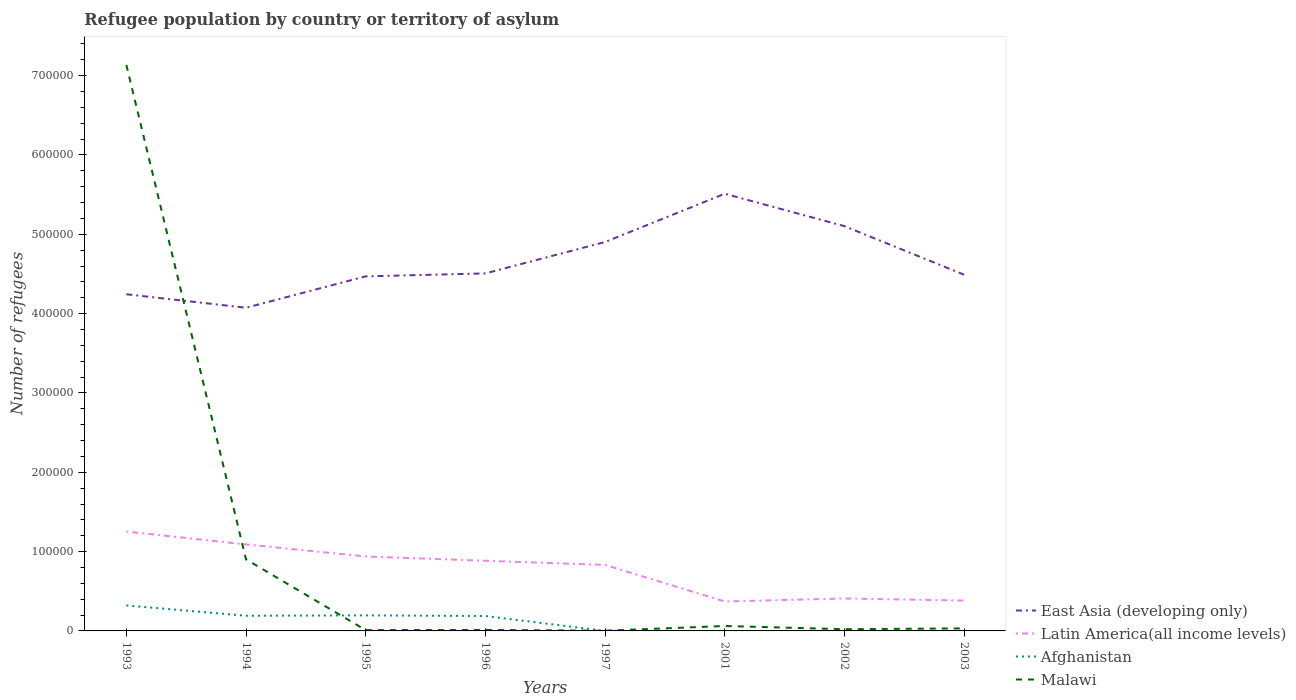Does the line corresponding to Malawi intersect with the line corresponding to Afghanistan?
Offer a terse response. Yes. Across all years, what is the maximum number of refugees in Malawi?
Your answer should be compact. 280. In which year was the number of refugees in Afghanistan maximum?
Your response must be concise. 2002. What is the total number of refugees in Latin America(all income levels) in the graph?
Your response must be concise. 5437. What is the difference between the highest and the second highest number of refugees in Malawi?
Your answer should be very brief. 7.13e+05. What is the difference between the highest and the lowest number of refugees in Malawi?
Provide a short and direct response. 1. What is the difference between two consecutive major ticks on the Y-axis?
Keep it short and to the point. 1.00e+05. Are the values on the major ticks of Y-axis written in scientific E-notation?
Make the answer very short. No. Does the graph contain any zero values?
Your response must be concise. No. How many legend labels are there?
Provide a succinct answer. 4. How are the legend labels stacked?
Your answer should be very brief. Vertical. What is the title of the graph?
Your answer should be very brief. Refugee population by country or territory of asylum. What is the label or title of the X-axis?
Your response must be concise. Years. What is the label or title of the Y-axis?
Your response must be concise. Number of refugees. What is the Number of refugees in East Asia (developing only) in 1993?
Give a very brief answer. 4.24e+05. What is the Number of refugees of Latin America(all income levels) in 1993?
Offer a terse response. 1.25e+05. What is the Number of refugees of Afghanistan in 1993?
Your answer should be compact. 3.21e+04. What is the Number of refugees in Malawi in 1993?
Your response must be concise. 7.14e+05. What is the Number of refugees in East Asia (developing only) in 1994?
Keep it short and to the point. 4.07e+05. What is the Number of refugees of Latin America(all income levels) in 1994?
Your answer should be compact. 1.09e+05. What is the Number of refugees in Afghanistan in 1994?
Your response must be concise. 1.91e+04. What is the Number of refugees of Malawi in 1994?
Offer a very short reply. 9.02e+04. What is the Number of refugees of East Asia (developing only) in 1995?
Offer a terse response. 4.47e+05. What is the Number of refugees of Latin America(all income levels) in 1995?
Your response must be concise. 9.39e+04. What is the Number of refugees of Afghanistan in 1995?
Provide a succinct answer. 1.96e+04. What is the Number of refugees of Malawi in 1995?
Provide a succinct answer. 1018. What is the Number of refugees in East Asia (developing only) in 1996?
Your answer should be compact. 4.51e+05. What is the Number of refugees in Latin America(all income levels) in 1996?
Make the answer very short. 8.84e+04. What is the Number of refugees in Afghanistan in 1996?
Offer a terse response. 1.88e+04. What is the Number of refugees in Malawi in 1996?
Give a very brief answer. 1268. What is the Number of refugees of East Asia (developing only) in 1997?
Keep it short and to the point. 4.90e+05. What is the Number of refugees in Latin America(all income levels) in 1997?
Ensure brevity in your answer.  8.32e+04. What is the Number of refugees of Afghanistan in 1997?
Your response must be concise. 5. What is the Number of refugees of Malawi in 1997?
Make the answer very short. 280. What is the Number of refugees in East Asia (developing only) in 2001?
Keep it short and to the point. 5.51e+05. What is the Number of refugees of Latin America(all income levels) in 2001?
Offer a very short reply. 3.71e+04. What is the Number of refugees of Malawi in 2001?
Ensure brevity in your answer.  6200. What is the Number of refugees in East Asia (developing only) in 2002?
Make the answer very short. 5.10e+05. What is the Number of refugees of Latin America(all income levels) in 2002?
Provide a short and direct response. 4.09e+04. What is the Number of refugees in Malawi in 2002?
Provide a succinct answer. 2166. What is the Number of refugees of East Asia (developing only) in 2003?
Make the answer very short. 4.49e+05. What is the Number of refugees in Latin America(all income levels) in 2003?
Give a very brief answer. 3.83e+04. What is the Number of refugees of Malawi in 2003?
Provide a short and direct response. 3202. Across all years, what is the maximum Number of refugees of East Asia (developing only)?
Ensure brevity in your answer.  5.51e+05. Across all years, what is the maximum Number of refugees of Latin America(all income levels)?
Your response must be concise. 1.25e+05. Across all years, what is the maximum Number of refugees in Afghanistan?
Your response must be concise. 3.21e+04. Across all years, what is the maximum Number of refugees in Malawi?
Ensure brevity in your answer.  7.14e+05. Across all years, what is the minimum Number of refugees of East Asia (developing only)?
Keep it short and to the point. 4.07e+05. Across all years, what is the minimum Number of refugees of Latin America(all income levels)?
Your answer should be very brief. 3.71e+04. Across all years, what is the minimum Number of refugees of Afghanistan?
Provide a short and direct response. 3. Across all years, what is the minimum Number of refugees of Malawi?
Give a very brief answer. 280. What is the total Number of refugees in East Asia (developing only) in the graph?
Provide a short and direct response. 3.73e+06. What is the total Number of refugees of Latin America(all income levels) in the graph?
Make the answer very short. 6.16e+05. What is the total Number of refugees of Afghanistan in the graph?
Give a very brief answer. 8.97e+04. What is the total Number of refugees of Malawi in the graph?
Keep it short and to the point. 8.18e+05. What is the difference between the Number of refugees of East Asia (developing only) in 1993 and that in 1994?
Ensure brevity in your answer.  1.70e+04. What is the difference between the Number of refugees in Latin America(all income levels) in 1993 and that in 1994?
Give a very brief answer. 1.62e+04. What is the difference between the Number of refugees in Afghanistan in 1993 and that in 1994?
Give a very brief answer. 1.30e+04. What is the difference between the Number of refugees in Malawi in 1993 and that in 1994?
Provide a succinct answer. 6.23e+05. What is the difference between the Number of refugees of East Asia (developing only) in 1993 and that in 1995?
Ensure brevity in your answer.  -2.25e+04. What is the difference between the Number of refugees in Latin America(all income levels) in 1993 and that in 1995?
Provide a succinct answer. 3.14e+04. What is the difference between the Number of refugees in Afghanistan in 1993 and that in 1995?
Your answer should be compact. 1.25e+04. What is the difference between the Number of refugees of Malawi in 1993 and that in 1995?
Offer a terse response. 7.13e+05. What is the difference between the Number of refugees in East Asia (developing only) in 1993 and that in 1996?
Offer a terse response. -2.63e+04. What is the difference between the Number of refugees in Latin America(all income levels) in 1993 and that in 1996?
Make the answer very short. 3.69e+04. What is the difference between the Number of refugees of Afghanistan in 1993 and that in 1996?
Offer a very short reply. 1.34e+04. What is the difference between the Number of refugees in Malawi in 1993 and that in 1996?
Make the answer very short. 7.12e+05. What is the difference between the Number of refugees in East Asia (developing only) in 1993 and that in 1997?
Give a very brief answer. -6.59e+04. What is the difference between the Number of refugees in Latin America(all income levels) in 1993 and that in 1997?
Provide a short and direct response. 4.21e+04. What is the difference between the Number of refugees of Afghanistan in 1993 and that in 1997?
Offer a very short reply. 3.21e+04. What is the difference between the Number of refugees of Malawi in 1993 and that in 1997?
Your answer should be very brief. 7.13e+05. What is the difference between the Number of refugees of East Asia (developing only) in 1993 and that in 2001?
Offer a terse response. -1.27e+05. What is the difference between the Number of refugees of Latin America(all income levels) in 1993 and that in 2001?
Offer a very short reply. 8.82e+04. What is the difference between the Number of refugees of Afghanistan in 1993 and that in 2001?
Make the answer very short. 3.21e+04. What is the difference between the Number of refugees in Malawi in 1993 and that in 2001?
Make the answer very short. 7.07e+05. What is the difference between the Number of refugees of East Asia (developing only) in 1993 and that in 2002?
Give a very brief answer. -8.59e+04. What is the difference between the Number of refugees in Latin America(all income levels) in 1993 and that in 2002?
Make the answer very short. 8.44e+04. What is the difference between the Number of refugees in Afghanistan in 1993 and that in 2002?
Ensure brevity in your answer.  3.21e+04. What is the difference between the Number of refugees of Malawi in 1993 and that in 2002?
Make the answer very short. 7.11e+05. What is the difference between the Number of refugees of East Asia (developing only) in 1993 and that in 2003?
Your response must be concise. -2.47e+04. What is the difference between the Number of refugees of Latin America(all income levels) in 1993 and that in 2003?
Offer a terse response. 8.70e+04. What is the difference between the Number of refugees of Afghanistan in 1993 and that in 2003?
Provide a succinct answer. 3.21e+04. What is the difference between the Number of refugees in Malawi in 1993 and that in 2003?
Give a very brief answer. 7.10e+05. What is the difference between the Number of refugees in East Asia (developing only) in 1994 and that in 1995?
Give a very brief answer. -3.96e+04. What is the difference between the Number of refugees of Latin America(all income levels) in 1994 and that in 1995?
Give a very brief answer. 1.52e+04. What is the difference between the Number of refugees in Afghanistan in 1994 and that in 1995?
Give a very brief answer. -474. What is the difference between the Number of refugees of Malawi in 1994 and that in 1995?
Provide a short and direct response. 8.92e+04. What is the difference between the Number of refugees of East Asia (developing only) in 1994 and that in 1996?
Provide a short and direct response. -4.33e+04. What is the difference between the Number of refugees in Latin America(all income levels) in 1994 and that in 1996?
Keep it short and to the point. 2.06e+04. What is the difference between the Number of refugees of Afghanistan in 1994 and that in 1996?
Your answer should be compact. 356. What is the difference between the Number of refugees in Malawi in 1994 and that in 1996?
Ensure brevity in your answer.  8.90e+04. What is the difference between the Number of refugees of East Asia (developing only) in 1994 and that in 1997?
Your response must be concise. -8.29e+04. What is the difference between the Number of refugees of Latin America(all income levels) in 1994 and that in 1997?
Your answer should be compact. 2.58e+04. What is the difference between the Number of refugees in Afghanistan in 1994 and that in 1997?
Offer a terse response. 1.91e+04. What is the difference between the Number of refugees of Malawi in 1994 and that in 1997?
Your answer should be compact. 9.00e+04. What is the difference between the Number of refugees of East Asia (developing only) in 1994 and that in 2001?
Your answer should be compact. -1.44e+05. What is the difference between the Number of refugees in Latin America(all income levels) in 1994 and that in 2001?
Offer a terse response. 7.19e+04. What is the difference between the Number of refugees of Afghanistan in 1994 and that in 2001?
Provide a succinct answer. 1.91e+04. What is the difference between the Number of refugees in Malawi in 1994 and that in 2001?
Give a very brief answer. 8.40e+04. What is the difference between the Number of refugees of East Asia (developing only) in 1994 and that in 2002?
Keep it short and to the point. -1.03e+05. What is the difference between the Number of refugees of Latin America(all income levels) in 1994 and that in 2002?
Your response must be concise. 6.82e+04. What is the difference between the Number of refugees in Afghanistan in 1994 and that in 2002?
Provide a short and direct response. 1.91e+04. What is the difference between the Number of refugees of Malawi in 1994 and that in 2002?
Your answer should be compact. 8.81e+04. What is the difference between the Number of refugees of East Asia (developing only) in 1994 and that in 2003?
Keep it short and to the point. -4.17e+04. What is the difference between the Number of refugees of Latin America(all income levels) in 1994 and that in 2003?
Make the answer very short. 7.07e+04. What is the difference between the Number of refugees of Afghanistan in 1994 and that in 2003?
Offer a terse response. 1.91e+04. What is the difference between the Number of refugees in Malawi in 1994 and that in 2003?
Provide a short and direct response. 8.70e+04. What is the difference between the Number of refugees of East Asia (developing only) in 1995 and that in 1996?
Offer a terse response. -3745. What is the difference between the Number of refugees in Latin America(all income levels) in 1995 and that in 1996?
Make the answer very short. 5437. What is the difference between the Number of refugees of Afghanistan in 1995 and that in 1996?
Your answer should be very brief. 830. What is the difference between the Number of refugees in Malawi in 1995 and that in 1996?
Provide a succinct answer. -250. What is the difference between the Number of refugees of East Asia (developing only) in 1995 and that in 1997?
Give a very brief answer. -4.33e+04. What is the difference between the Number of refugees of Latin America(all income levels) in 1995 and that in 1997?
Provide a succinct answer. 1.06e+04. What is the difference between the Number of refugees of Afghanistan in 1995 and that in 1997?
Provide a succinct answer. 1.96e+04. What is the difference between the Number of refugees in Malawi in 1995 and that in 1997?
Offer a very short reply. 738. What is the difference between the Number of refugees in East Asia (developing only) in 1995 and that in 2001?
Your response must be concise. -1.04e+05. What is the difference between the Number of refugees of Latin America(all income levels) in 1995 and that in 2001?
Provide a short and direct response. 5.67e+04. What is the difference between the Number of refugees of Afghanistan in 1995 and that in 2001?
Give a very brief answer. 1.96e+04. What is the difference between the Number of refugees in Malawi in 1995 and that in 2001?
Give a very brief answer. -5182. What is the difference between the Number of refugees of East Asia (developing only) in 1995 and that in 2002?
Your answer should be compact. -6.33e+04. What is the difference between the Number of refugees of Latin America(all income levels) in 1995 and that in 2002?
Give a very brief answer. 5.30e+04. What is the difference between the Number of refugees of Afghanistan in 1995 and that in 2002?
Provide a short and direct response. 1.96e+04. What is the difference between the Number of refugees of Malawi in 1995 and that in 2002?
Offer a terse response. -1148. What is the difference between the Number of refugees of East Asia (developing only) in 1995 and that in 2003?
Make the answer very short. -2123. What is the difference between the Number of refugees in Latin America(all income levels) in 1995 and that in 2003?
Ensure brevity in your answer.  5.56e+04. What is the difference between the Number of refugees of Afghanistan in 1995 and that in 2003?
Your answer should be very brief. 1.96e+04. What is the difference between the Number of refugees of Malawi in 1995 and that in 2003?
Give a very brief answer. -2184. What is the difference between the Number of refugees of East Asia (developing only) in 1996 and that in 1997?
Provide a succinct answer. -3.96e+04. What is the difference between the Number of refugees of Latin America(all income levels) in 1996 and that in 1997?
Your answer should be compact. 5201. What is the difference between the Number of refugees of Afghanistan in 1996 and that in 1997?
Your answer should be very brief. 1.88e+04. What is the difference between the Number of refugees in Malawi in 1996 and that in 1997?
Offer a terse response. 988. What is the difference between the Number of refugees of East Asia (developing only) in 1996 and that in 2001?
Provide a succinct answer. -1.00e+05. What is the difference between the Number of refugees in Latin America(all income levels) in 1996 and that in 2001?
Provide a succinct answer. 5.13e+04. What is the difference between the Number of refugees in Afghanistan in 1996 and that in 2001?
Provide a succinct answer. 1.88e+04. What is the difference between the Number of refugees in Malawi in 1996 and that in 2001?
Provide a succinct answer. -4932. What is the difference between the Number of refugees in East Asia (developing only) in 1996 and that in 2002?
Ensure brevity in your answer.  -5.96e+04. What is the difference between the Number of refugees in Latin America(all income levels) in 1996 and that in 2002?
Your response must be concise. 4.75e+04. What is the difference between the Number of refugees in Afghanistan in 1996 and that in 2002?
Give a very brief answer. 1.88e+04. What is the difference between the Number of refugees in Malawi in 1996 and that in 2002?
Ensure brevity in your answer.  -898. What is the difference between the Number of refugees in East Asia (developing only) in 1996 and that in 2003?
Ensure brevity in your answer.  1622. What is the difference between the Number of refugees of Latin America(all income levels) in 1996 and that in 2003?
Provide a succinct answer. 5.01e+04. What is the difference between the Number of refugees in Afghanistan in 1996 and that in 2003?
Your answer should be compact. 1.88e+04. What is the difference between the Number of refugees of Malawi in 1996 and that in 2003?
Offer a very short reply. -1934. What is the difference between the Number of refugees in East Asia (developing only) in 1997 and that in 2001?
Ensure brevity in your answer.  -6.08e+04. What is the difference between the Number of refugees in Latin America(all income levels) in 1997 and that in 2001?
Keep it short and to the point. 4.61e+04. What is the difference between the Number of refugees in Malawi in 1997 and that in 2001?
Provide a succinct answer. -5920. What is the difference between the Number of refugees in East Asia (developing only) in 1997 and that in 2002?
Your answer should be very brief. -2.00e+04. What is the difference between the Number of refugees of Latin America(all income levels) in 1997 and that in 2002?
Offer a very short reply. 4.23e+04. What is the difference between the Number of refugees of Malawi in 1997 and that in 2002?
Offer a very short reply. -1886. What is the difference between the Number of refugees of East Asia (developing only) in 1997 and that in 2003?
Offer a terse response. 4.12e+04. What is the difference between the Number of refugees of Latin America(all income levels) in 1997 and that in 2003?
Make the answer very short. 4.49e+04. What is the difference between the Number of refugees of Afghanistan in 1997 and that in 2003?
Ensure brevity in your answer.  -17. What is the difference between the Number of refugees of Malawi in 1997 and that in 2003?
Provide a succinct answer. -2922. What is the difference between the Number of refugees in East Asia (developing only) in 2001 and that in 2002?
Offer a very short reply. 4.08e+04. What is the difference between the Number of refugees of Latin America(all income levels) in 2001 and that in 2002?
Offer a very short reply. -3747. What is the difference between the Number of refugees in Malawi in 2001 and that in 2002?
Keep it short and to the point. 4034. What is the difference between the Number of refugees in East Asia (developing only) in 2001 and that in 2003?
Make the answer very short. 1.02e+05. What is the difference between the Number of refugees in Latin America(all income levels) in 2001 and that in 2003?
Offer a terse response. -1168. What is the difference between the Number of refugees in Malawi in 2001 and that in 2003?
Your answer should be compact. 2998. What is the difference between the Number of refugees of East Asia (developing only) in 2002 and that in 2003?
Your answer should be compact. 6.12e+04. What is the difference between the Number of refugees in Latin America(all income levels) in 2002 and that in 2003?
Provide a short and direct response. 2579. What is the difference between the Number of refugees in Afghanistan in 2002 and that in 2003?
Ensure brevity in your answer.  -19. What is the difference between the Number of refugees of Malawi in 2002 and that in 2003?
Provide a short and direct response. -1036. What is the difference between the Number of refugees in East Asia (developing only) in 1993 and the Number of refugees in Latin America(all income levels) in 1994?
Offer a terse response. 3.15e+05. What is the difference between the Number of refugees of East Asia (developing only) in 1993 and the Number of refugees of Afghanistan in 1994?
Ensure brevity in your answer.  4.05e+05. What is the difference between the Number of refugees of East Asia (developing only) in 1993 and the Number of refugees of Malawi in 1994?
Make the answer very short. 3.34e+05. What is the difference between the Number of refugees in Latin America(all income levels) in 1993 and the Number of refugees in Afghanistan in 1994?
Your answer should be compact. 1.06e+05. What is the difference between the Number of refugees of Latin America(all income levels) in 1993 and the Number of refugees of Malawi in 1994?
Give a very brief answer. 3.50e+04. What is the difference between the Number of refugees of Afghanistan in 1993 and the Number of refugees of Malawi in 1994?
Ensure brevity in your answer.  -5.81e+04. What is the difference between the Number of refugees in East Asia (developing only) in 1993 and the Number of refugees in Latin America(all income levels) in 1995?
Offer a terse response. 3.31e+05. What is the difference between the Number of refugees of East Asia (developing only) in 1993 and the Number of refugees of Afghanistan in 1995?
Provide a short and direct response. 4.05e+05. What is the difference between the Number of refugees of East Asia (developing only) in 1993 and the Number of refugees of Malawi in 1995?
Make the answer very short. 4.23e+05. What is the difference between the Number of refugees in Latin America(all income levels) in 1993 and the Number of refugees in Afghanistan in 1995?
Your answer should be very brief. 1.06e+05. What is the difference between the Number of refugees of Latin America(all income levels) in 1993 and the Number of refugees of Malawi in 1995?
Offer a very short reply. 1.24e+05. What is the difference between the Number of refugees in Afghanistan in 1993 and the Number of refugees in Malawi in 1995?
Make the answer very short. 3.11e+04. What is the difference between the Number of refugees in East Asia (developing only) in 1993 and the Number of refugees in Latin America(all income levels) in 1996?
Offer a terse response. 3.36e+05. What is the difference between the Number of refugees in East Asia (developing only) in 1993 and the Number of refugees in Afghanistan in 1996?
Give a very brief answer. 4.06e+05. What is the difference between the Number of refugees of East Asia (developing only) in 1993 and the Number of refugees of Malawi in 1996?
Your response must be concise. 4.23e+05. What is the difference between the Number of refugees of Latin America(all income levels) in 1993 and the Number of refugees of Afghanistan in 1996?
Your answer should be compact. 1.07e+05. What is the difference between the Number of refugees in Latin America(all income levels) in 1993 and the Number of refugees in Malawi in 1996?
Give a very brief answer. 1.24e+05. What is the difference between the Number of refugees in Afghanistan in 1993 and the Number of refugees in Malawi in 1996?
Your response must be concise. 3.09e+04. What is the difference between the Number of refugees in East Asia (developing only) in 1993 and the Number of refugees in Latin America(all income levels) in 1997?
Provide a succinct answer. 3.41e+05. What is the difference between the Number of refugees of East Asia (developing only) in 1993 and the Number of refugees of Afghanistan in 1997?
Your answer should be very brief. 4.24e+05. What is the difference between the Number of refugees of East Asia (developing only) in 1993 and the Number of refugees of Malawi in 1997?
Make the answer very short. 4.24e+05. What is the difference between the Number of refugees of Latin America(all income levels) in 1993 and the Number of refugees of Afghanistan in 1997?
Offer a terse response. 1.25e+05. What is the difference between the Number of refugees in Latin America(all income levels) in 1993 and the Number of refugees in Malawi in 1997?
Keep it short and to the point. 1.25e+05. What is the difference between the Number of refugees in Afghanistan in 1993 and the Number of refugees in Malawi in 1997?
Make the answer very short. 3.19e+04. What is the difference between the Number of refugees of East Asia (developing only) in 1993 and the Number of refugees of Latin America(all income levels) in 2001?
Provide a succinct answer. 3.87e+05. What is the difference between the Number of refugees in East Asia (developing only) in 1993 and the Number of refugees in Afghanistan in 2001?
Offer a very short reply. 4.24e+05. What is the difference between the Number of refugees of East Asia (developing only) in 1993 and the Number of refugees of Malawi in 2001?
Offer a very short reply. 4.18e+05. What is the difference between the Number of refugees in Latin America(all income levels) in 1993 and the Number of refugees in Afghanistan in 2001?
Offer a very short reply. 1.25e+05. What is the difference between the Number of refugees of Latin America(all income levels) in 1993 and the Number of refugees of Malawi in 2001?
Your answer should be compact. 1.19e+05. What is the difference between the Number of refugees in Afghanistan in 1993 and the Number of refugees in Malawi in 2001?
Offer a terse response. 2.59e+04. What is the difference between the Number of refugees of East Asia (developing only) in 1993 and the Number of refugees of Latin America(all income levels) in 2002?
Your answer should be very brief. 3.84e+05. What is the difference between the Number of refugees in East Asia (developing only) in 1993 and the Number of refugees in Afghanistan in 2002?
Provide a succinct answer. 4.24e+05. What is the difference between the Number of refugees in East Asia (developing only) in 1993 and the Number of refugees in Malawi in 2002?
Your answer should be compact. 4.22e+05. What is the difference between the Number of refugees in Latin America(all income levels) in 1993 and the Number of refugees in Afghanistan in 2002?
Ensure brevity in your answer.  1.25e+05. What is the difference between the Number of refugees in Latin America(all income levels) in 1993 and the Number of refugees in Malawi in 2002?
Ensure brevity in your answer.  1.23e+05. What is the difference between the Number of refugees of Afghanistan in 1993 and the Number of refugees of Malawi in 2002?
Provide a succinct answer. 3.00e+04. What is the difference between the Number of refugees of East Asia (developing only) in 1993 and the Number of refugees of Latin America(all income levels) in 2003?
Provide a succinct answer. 3.86e+05. What is the difference between the Number of refugees in East Asia (developing only) in 1993 and the Number of refugees in Afghanistan in 2003?
Offer a very short reply. 4.24e+05. What is the difference between the Number of refugees of East Asia (developing only) in 1993 and the Number of refugees of Malawi in 2003?
Offer a terse response. 4.21e+05. What is the difference between the Number of refugees in Latin America(all income levels) in 1993 and the Number of refugees in Afghanistan in 2003?
Your answer should be compact. 1.25e+05. What is the difference between the Number of refugees of Latin America(all income levels) in 1993 and the Number of refugees of Malawi in 2003?
Offer a very short reply. 1.22e+05. What is the difference between the Number of refugees of Afghanistan in 1993 and the Number of refugees of Malawi in 2003?
Give a very brief answer. 2.89e+04. What is the difference between the Number of refugees of East Asia (developing only) in 1994 and the Number of refugees of Latin America(all income levels) in 1995?
Ensure brevity in your answer.  3.14e+05. What is the difference between the Number of refugees in East Asia (developing only) in 1994 and the Number of refugees in Afghanistan in 1995?
Make the answer very short. 3.88e+05. What is the difference between the Number of refugees of East Asia (developing only) in 1994 and the Number of refugees of Malawi in 1995?
Your answer should be very brief. 4.06e+05. What is the difference between the Number of refugees in Latin America(all income levels) in 1994 and the Number of refugees in Afghanistan in 1995?
Give a very brief answer. 8.94e+04. What is the difference between the Number of refugees of Latin America(all income levels) in 1994 and the Number of refugees of Malawi in 1995?
Provide a succinct answer. 1.08e+05. What is the difference between the Number of refugees in Afghanistan in 1994 and the Number of refugees in Malawi in 1995?
Offer a terse response. 1.81e+04. What is the difference between the Number of refugees in East Asia (developing only) in 1994 and the Number of refugees in Latin America(all income levels) in 1996?
Make the answer very short. 3.19e+05. What is the difference between the Number of refugees of East Asia (developing only) in 1994 and the Number of refugees of Afghanistan in 1996?
Provide a short and direct response. 3.89e+05. What is the difference between the Number of refugees of East Asia (developing only) in 1994 and the Number of refugees of Malawi in 1996?
Provide a succinct answer. 4.06e+05. What is the difference between the Number of refugees in Latin America(all income levels) in 1994 and the Number of refugees in Afghanistan in 1996?
Your response must be concise. 9.03e+04. What is the difference between the Number of refugees of Latin America(all income levels) in 1994 and the Number of refugees of Malawi in 1996?
Make the answer very short. 1.08e+05. What is the difference between the Number of refugees of Afghanistan in 1994 and the Number of refugees of Malawi in 1996?
Your answer should be very brief. 1.79e+04. What is the difference between the Number of refugees of East Asia (developing only) in 1994 and the Number of refugees of Latin America(all income levels) in 1997?
Your answer should be compact. 3.24e+05. What is the difference between the Number of refugees in East Asia (developing only) in 1994 and the Number of refugees in Afghanistan in 1997?
Offer a very short reply. 4.07e+05. What is the difference between the Number of refugees in East Asia (developing only) in 1994 and the Number of refugees in Malawi in 1997?
Make the answer very short. 4.07e+05. What is the difference between the Number of refugees in Latin America(all income levels) in 1994 and the Number of refugees in Afghanistan in 1997?
Your answer should be very brief. 1.09e+05. What is the difference between the Number of refugees in Latin America(all income levels) in 1994 and the Number of refugees in Malawi in 1997?
Offer a very short reply. 1.09e+05. What is the difference between the Number of refugees in Afghanistan in 1994 and the Number of refugees in Malawi in 1997?
Provide a short and direct response. 1.89e+04. What is the difference between the Number of refugees in East Asia (developing only) in 1994 and the Number of refugees in Latin America(all income levels) in 2001?
Make the answer very short. 3.70e+05. What is the difference between the Number of refugees in East Asia (developing only) in 1994 and the Number of refugees in Afghanistan in 2001?
Offer a terse response. 4.07e+05. What is the difference between the Number of refugees of East Asia (developing only) in 1994 and the Number of refugees of Malawi in 2001?
Your answer should be very brief. 4.01e+05. What is the difference between the Number of refugees of Latin America(all income levels) in 1994 and the Number of refugees of Afghanistan in 2001?
Ensure brevity in your answer.  1.09e+05. What is the difference between the Number of refugees in Latin America(all income levels) in 1994 and the Number of refugees in Malawi in 2001?
Provide a short and direct response. 1.03e+05. What is the difference between the Number of refugees of Afghanistan in 1994 and the Number of refugees of Malawi in 2001?
Provide a short and direct response. 1.29e+04. What is the difference between the Number of refugees of East Asia (developing only) in 1994 and the Number of refugees of Latin America(all income levels) in 2002?
Provide a short and direct response. 3.67e+05. What is the difference between the Number of refugees in East Asia (developing only) in 1994 and the Number of refugees in Afghanistan in 2002?
Provide a succinct answer. 4.07e+05. What is the difference between the Number of refugees in East Asia (developing only) in 1994 and the Number of refugees in Malawi in 2002?
Make the answer very short. 4.05e+05. What is the difference between the Number of refugees of Latin America(all income levels) in 1994 and the Number of refugees of Afghanistan in 2002?
Make the answer very short. 1.09e+05. What is the difference between the Number of refugees of Latin America(all income levels) in 1994 and the Number of refugees of Malawi in 2002?
Ensure brevity in your answer.  1.07e+05. What is the difference between the Number of refugees in Afghanistan in 1994 and the Number of refugees in Malawi in 2002?
Your answer should be compact. 1.70e+04. What is the difference between the Number of refugees of East Asia (developing only) in 1994 and the Number of refugees of Latin America(all income levels) in 2003?
Offer a terse response. 3.69e+05. What is the difference between the Number of refugees in East Asia (developing only) in 1994 and the Number of refugees in Afghanistan in 2003?
Offer a terse response. 4.07e+05. What is the difference between the Number of refugees in East Asia (developing only) in 1994 and the Number of refugees in Malawi in 2003?
Keep it short and to the point. 4.04e+05. What is the difference between the Number of refugees in Latin America(all income levels) in 1994 and the Number of refugees in Afghanistan in 2003?
Give a very brief answer. 1.09e+05. What is the difference between the Number of refugees in Latin America(all income levels) in 1994 and the Number of refugees in Malawi in 2003?
Provide a succinct answer. 1.06e+05. What is the difference between the Number of refugees of Afghanistan in 1994 and the Number of refugees of Malawi in 2003?
Offer a terse response. 1.59e+04. What is the difference between the Number of refugees in East Asia (developing only) in 1995 and the Number of refugees in Latin America(all income levels) in 1996?
Ensure brevity in your answer.  3.59e+05. What is the difference between the Number of refugees in East Asia (developing only) in 1995 and the Number of refugees in Afghanistan in 1996?
Make the answer very short. 4.28e+05. What is the difference between the Number of refugees of East Asia (developing only) in 1995 and the Number of refugees of Malawi in 1996?
Offer a very short reply. 4.46e+05. What is the difference between the Number of refugees in Latin America(all income levels) in 1995 and the Number of refugees in Afghanistan in 1996?
Ensure brevity in your answer.  7.51e+04. What is the difference between the Number of refugees in Latin America(all income levels) in 1995 and the Number of refugees in Malawi in 1996?
Provide a succinct answer. 9.26e+04. What is the difference between the Number of refugees in Afghanistan in 1995 and the Number of refugees in Malawi in 1996?
Your response must be concise. 1.83e+04. What is the difference between the Number of refugees of East Asia (developing only) in 1995 and the Number of refugees of Latin America(all income levels) in 1997?
Ensure brevity in your answer.  3.64e+05. What is the difference between the Number of refugees of East Asia (developing only) in 1995 and the Number of refugees of Afghanistan in 1997?
Offer a very short reply. 4.47e+05. What is the difference between the Number of refugees of East Asia (developing only) in 1995 and the Number of refugees of Malawi in 1997?
Your answer should be compact. 4.47e+05. What is the difference between the Number of refugees of Latin America(all income levels) in 1995 and the Number of refugees of Afghanistan in 1997?
Your answer should be very brief. 9.39e+04. What is the difference between the Number of refugees of Latin America(all income levels) in 1995 and the Number of refugees of Malawi in 1997?
Your answer should be compact. 9.36e+04. What is the difference between the Number of refugees in Afghanistan in 1995 and the Number of refugees in Malawi in 1997?
Make the answer very short. 1.93e+04. What is the difference between the Number of refugees of East Asia (developing only) in 1995 and the Number of refugees of Latin America(all income levels) in 2001?
Your response must be concise. 4.10e+05. What is the difference between the Number of refugees in East Asia (developing only) in 1995 and the Number of refugees in Afghanistan in 2001?
Ensure brevity in your answer.  4.47e+05. What is the difference between the Number of refugees of East Asia (developing only) in 1995 and the Number of refugees of Malawi in 2001?
Ensure brevity in your answer.  4.41e+05. What is the difference between the Number of refugees of Latin America(all income levels) in 1995 and the Number of refugees of Afghanistan in 2001?
Offer a very short reply. 9.39e+04. What is the difference between the Number of refugees of Latin America(all income levels) in 1995 and the Number of refugees of Malawi in 2001?
Your response must be concise. 8.77e+04. What is the difference between the Number of refugees in Afghanistan in 1995 and the Number of refugees in Malawi in 2001?
Keep it short and to the point. 1.34e+04. What is the difference between the Number of refugees of East Asia (developing only) in 1995 and the Number of refugees of Latin America(all income levels) in 2002?
Offer a very short reply. 4.06e+05. What is the difference between the Number of refugees of East Asia (developing only) in 1995 and the Number of refugees of Afghanistan in 2002?
Make the answer very short. 4.47e+05. What is the difference between the Number of refugees of East Asia (developing only) in 1995 and the Number of refugees of Malawi in 2002?
Offer a very short reply. 4.45e+05. What is the difference between the Number of refugees of Latin America(all income levels) in 1995 and the Number of refugees of Afghanistan in 2002?
Provide a succinct answer. 9.39e+04. What is the difference between the Number of refugees of Latin America(all income levels) in 1995 and the Number of refugees of Malawi in 2002?
Your response must be concise. 9.17e+04. What is the difference between the Number of refugees in Afghanistan in 1995 and the Number of refugees in Malawi in 2002?
Your answer should be compact. 1.74e+04. What is the difference between the Number of refugees in East Asia (developing only) in 1995 and the Number of refugees in Latin America(all income levels) in 2003?
Offer a very short reply. 4.09e+05. What is the difference between the Number of refugees in East Asia (developing only) in 1995 and the Number of refugees in Afghanistan in 2003?
Offer a very short reply. 4.47e+05. What is the difference between the Number of refugees in East Asia (developing only) in 1995 and the Number of refugees in Malawi in 2003?
Your answer should be compact. 4.44e+05. What is the difference between the Number of refugees in Latin America(all income levels) in 1995 and the Number of refugees in Afghanistan in 2003?
Your answer should be compact. 9.38e+04. What is the difference between the Number of refugees of Latin America(all income levels) in 1995 and the Number of refugees of Malawi in 2003?
Ensure brevity in your answer.  9.07e+04. What is the difference between the Number of refugees in Afghanistan in 1995 and the Number of refugees in Malawi in 2003?
Make the answer very short. 1.64e+04. What is the difference between the Number of refugees of East Asia (developing only) in 1996 and the Number of refugees of Latin America(all income levels) in 1997?
Offer a very short reply. 3.68e+05. What is the difference between the Number of refugees in East Asia (developing only) in 1996 and the Number of refugees in Afghanistan in 1997?
Your answer should be compact. 4.51e+05. What is the difference between the Number of refugees of East Asia (developing only) in 1996 and the Number of refugees of Malawi in 1997?
Your response must be concise. 4.50e+05. What is the difference between the Number of refugees of Latin America(all income levels) in 1996 and the Number of refugees of Afghanistan in 1997?
Your answer should be very brief. 8.84e+04. What is the difference between the Number of refugees of Latin America(all income levels) in 1996 and the Number of refugees of Malawi in 1997?
Ensure brevity in your answer.  8.81e+04. What is the difference between the Number of refugees in Afghanistan in 1996 and the Number of refugees in Malawi in 1997?
Offer a terse response. 1.85e+04. What is the difference between the Number of refugees in East Asia (developing only) in 1996 and the Number of refugees in Latin America(all income levels) in 2001?
Ensure brevity in your answer.  4.14e+05. What is the difference between the Number of refugees of East Asia (developing only) in 1996 and the Number of refugees of Afghanistan in 2001?
Your answer should be very brief. 4.51e+05. What is the difference between the Number of refugees in East Asia (developing only) in 1996 and the Number of refugees in Malawi in 2001?
Offer a very short reply. 4.45e+05. What is the difference between the Number of refugees in Latin America(all income levels) in 1996 and the Number of refugees in Afghanistan in 2001?
Make the answer very short. 8.84e+04. What is the difference between the Number of refugees in Latin America(all income levels) in 1996 and the Number of refugees in Malawi in 2001?
Your answer should be very brief. 8.22e+04. What is the difference between the Number of refugees of Afghanistan in 1996 and the Number of refugees of Malawi in 2001?
Your response must be concise. 1.26e+04. What is the difference between the Number of refugees of East Asia (developing only) in 1996 and the Number of refugees of Latin America(all income levels) in 2002?
Offer a very short reply. 4.10e+05. What is the difference between the Number of refugees of East Asia (developing only) in 1996 and the Number of refugees of Afghanistan in 2002?
Your answer should be very brief. 4.51e+05. What is the difference between the Number of refugees of East Asia (developing only) in 1996 and the Number of refugees of Malawi in 2002?
Keep it short and to the point. 4.49e+05. What is the difference between the Number of refugees in Latin America(all income levels) in 1996 and the Number of refugees in Afghanistan in 2002?
Your answer should be compact. 8.84e+04. What is the difference between the Number of refugees of Latin America(all income levels) in 1996 and the Number of refugees of Malawi in 2002?
Provide a short and direct response. 8.63e+04. What is the difference between the Number of refugees in Afghanistan in 1996 and the Number of refugees in Malawi in 2002?
Make the answer very short. 1.66e+04. What is the difference between the Number of refugees of East Asia (developing only) in 1996 and the Number of refugees of Latin America(all income levels) in 2003?
Make the answer very short. 4.12e+05. What is the difference between the Number of refugees in East Asia (developing only) in 1996 and the Number of refugees in Afghanistan in 2003?
Ensure brevity in your answer.  4.51e+05. What is the difference between the Number of refugees in East Asia (developing only) in 1996 and the Number of refugees in Malawi in 2003?
Provide a short and direct response. 4.48e+05. What is the difference between the Number of refugees in Latin America(all income levels) in 1996 and the Number of refugees in Afghanistan in 2003?
Your answer should be compact. 8.84e+04. What is the difference between the Number of refugees of Latin America(all income levels) in 1996 and the Number of refugees of Malawi in 2003?
Keep it short and to the point. 8.52e+04. What is the difference between the Number of refugees in Afghanistan in 1996 and the Number of refugees in Malawi in 2003?
Ensure brevity in your answer.  1.56e+04. What is the difference between the Number of refugees in East Asia (developing only) in 1997 and the Number of refugees in Latin America(all income levels) in 2001?
Give a very brief answer. 4.53e+05. What is the difference between the Number of refugees of East Asia (developing only) in 1997 and the Number of refugees of Afghanistan in 2001?
Give a very brief answer. 4.90e+05. What is the difference between the Number of refugees of East Asia (developing only) in 1997 and the Number of refugees of Malawi in 2001?
Your answer should be compact. 4.84e+05. What is the difference between the Number of refugees of Latin America(all income levels) in 1997 and the Number of refugees of Afghanistan in 2001?
Your answer should be very brief. 8.32e+04. What is the difference between the Number of refugees of Latin America(all income levels) in 1997 and the Number of refugees of Malawi in 2001?
Ensure brevity in your answer.  7.70e+04. What is the difference between the Number of refugees in Afghanistan in 1997 and the Number of refugees in Malawi in 2001?
Give a very brief answer. -6195. What is the difference between the Number of refugees of East Asia (developing only) in 1997 and the Number of refugees of Latin America(all income levels) in 2002?
Your answer should be very brief. 4.49e+05. What is the difference between the Number of refugees of East Asia (developing only) in 1997 and the Number of refugees of Afghanistan in 2002?
Ensure brevity in your answer.  4.90e+05. What is the difference between the Number of refugees in East Asia (developing only) in 1997 and the Number of refugees in Malawi in 2002?
Your answer should be very brief. 4.88e+05. What is the difference between the Number of refugees in Latin America(all income levels) in 1997 and the Number of refugees in Afghanistan in 2002?
Your response must be concise. 8.32e+04. What is the difference between the Number of refugees in Latin America(all income levels) in 1997 and the Number of refugees in Malawi in 2002?
Your response must be concise. 8.11e+04. What is the difference between the Number of refugees of Afghanistan in 1997 and the Number of refugees of Malawi in 2002?
Provide a short and direct response. -2161. What is the difference between the Number of refugees in East Asia (developing only) in 1997 and the Number of refugees in Latin America(all income levels) in 2003?
Your answer should be very brief. 4.52e+05. What is the difference between the Number of refugees in East Asia (developing only) in 1997 and the Number of refugees in Afghanistan in 2003?
Give a very brief answer. 4.90e+05. What is the difference between the Number of refugees of East Asia (developing only) in 1997 and the Number of refugees of Malawi in 2003?
Give a very brief answer. 4.87e+05. What is the difference between the Number of refugees in Latin America(all income levels) in 1997 and the Number of refugees in Afghanistan in 2003?
Ensure brevity in your answer.  8.32e+04. What is the difference between the Number of refugees of Latin America(all income levels) in 1997 and the Number of refugees of Malawi in 2003?
Your response must be concise. 8.00e+04. What is the difference between the Number of refugees of Afghanistan in 1997 and the Number of refugees of Malawi in 2003?
Offer a terse response. -3197. What is the difference between the Number of refugees of East Asia (developing only) in 2001 and the Number of refugees of Latin America(all income levels) in 2002?
Ensure brevity in your answer.  5.10e+05. What is the difference between the Number of refugees in East Asia (developing only) in 2001 and the Number of refugees in Afghanistan in 2002?
Offer a terse response. 5.51e+05. What is the difference between the Number of refugees in East Asia (developing only) in 2001 and the Number of refugees in Malawi in 2002?
Keep it short and to the point. 5.49e+05. What is the difference between the Number of refugees in Latin America(all income levels) in 2001 and the Number of refugees in Afghanistan in 2002?
Give a very brief answer. 3.71e+04. What is the difference between the Number of refugees in Latin America(all income levels) in 2001 and the Number of refugees in Malawi in 2002?
Your answer should be compact. 3.50e+04. What is the difference between the Number of refugees in Afghanistan in 2001 and the Number of refugees in Malawi in 2002?
Provide a short and direct response. -2160. What is the difference between the Number of refugees of East Asia (developing only) in 2001 and the Number of refugees of Latin America(all income levels) in 2003?
Your response must be concise. 5.13e+05. What is the difference between the Number of refugees in East Asia (developing only) in 2001 and the Number of refugees in Afghanistan in 2003?
Provide a succinct answer. 5.51e+05. What is the difference between the Number of refugees of East Asia (developing only) in 2001 and the Number of refugees of Malawi in 2003?
Offer a very short reply. 5.48e+05. What is the difference between the Number of refugees in Latin America(all income levels) in 2001 and the Number of refugees in Afghanistan in 2003?
Offer a very short reply. 3.71e+04. What is the difference between the Number of refugees of Latin America(all income levels) in 2001 and the Number of refugees of Malawi in 2003?
Ensure brevity in your answer.  3.39e+04. What is the difference between the Number of refugees in Afghanistan in 2001 and the Number of refugees in Malawi in 2003?
Ensure brevity in your answer.  -3196. What is the difference between the Number of refugees in East Asia (developing only) in 2002 and the Number of refugees in Latin America(all income levels) in 2003?
Your response must be concise. 4.72e+05. What is the difference between the Number of refugees in East Asia (developing only) in 2002 and the Number of refugees in Afghanistan in 2003?
Provide a succinct answer. 5.10e+05. What is the difference between the Number of refugees in East Asia (developing only) in 2002 and the Number of refugees in Malawi in 2003?
Give a very brief answer. 5.07e+05. What is the difference between the Number of refugees in Latin America(all income levels) in 2002 and the Number of refugees in Afghanistan in 2003?
Your answer should be compact. 4.09e+04. What is the difference between the Number of refugees of Latin America(all income levels) in 2002 and the Number of refugees of Malawi in 2003?
Make the answer very short. 3.77e+04. What is the difference between the Number of refugees of Afghanistan in 2002 and the Number of refugees of Malawi in 2003?
Your answer should be very brief. -3199. What is the average Number of refugees in East Asia (developing only) per year?
Provide a short and direct response. 4.66e+05. What is the average Number of refugees in Latin America(all income levels) per year?
Give a very brief answer. 7.70e+04. What is the average Number of refugees of Afghanistan per year?
Provide a succinct answer. 1.12e+04. What is the average Number of refugees of Malawi per year?
Your answer should be compact. 1.02e+05. In the year 1993, what is the difference between the Number of refugees in East Asia (developing only) and Number of refugees in Latin America(all income levels)?
Your response must be concise. 2.99e+05. In the year 1993, what is the difference between the Number of refugees in East Asia (developing only) and Number of refugees in Afghanistan?
Offer a very short reply. 3.92e+05. In the year 1993, what is the difference between the Number of refugees of East Asia (developing only) and Number of refugees of Malawi?
Ensure brevity in your answer.  -2.89e+05. In the year 1993, what is the difference between the Number of refugees of Latin America(all income levels) and Number of refugees of Afghanistan?
Your response must be concise. 9.32e+04. In the year 1993, what is the difference between the Number of refugees in Latin America(all income levels) and Number of refugees in Malawi?
Offer a very short reply. -5.88e+05. In the year 1993, what is the difference between the Number of refugees in Afghanistan and Number of refugees in Malawi?
Your answer should be very brief. -6.81e+05. In the year 1994, what is the difference between the Number of refugees of East Asia (developing only) and Number of refugees of Latin America(all income levels)?
Keep it short and to the point. 2.98e+05. In the year 1994, what is the difference between the Number of refugees of East Asia (developing only) and Number of refugees of Afghanistan?
Your answer should be compact. 3.88e+05. In the year 1994, what is the difference between the Number of refugees of East Asia (developing only) and Number of refugees of Malawi?
Give a very brief answer. 3.17e+05. In the year 1994, what is the difference between the Number of refugees of Latin America(all income levels) and Number of refugees of Afghanistan?
Your answer should be very brief. 8.99e+04. In the year 1994, what is the difference between the Number of refugees of Latin America(all income levels) and Number of refugees of Malawi?
Provide a succinct answer. 1.88e+04. In the year 1994, what is the difference between the Number of refugees in Afghanistan and Number of refugees in Malawi?
Your answer should be compact. -7.11e+04. In the year 1995, what is the difference between the Number of refugees of East Asia (developing only) and Number of refugees of Latin America(all income levels)?
Ensure brevity in your answer.  3.53e+05. In the year 1995, what is the difference between the Number of refugees in East Asia (developing only) and Number of refugees in Afghanistan?
Provide a short and direct response. 4.27e+05. In the year 1995, what is the difference between the Number of refugees in East Asia (developing only) and Number of refugees in Malawi?
Your answer should be very brief. 4.46e+05. In the year 1995, what is the difference between the Number of refugees of Latin America(all income levels) and Number of refugees of Afghanistan?
Your response must be concise. 7.43e+04. In the year 1995, what is the difference between the Number of refugees of Latin America(all income levels) and Number of refugees of Malawi?
Provide a succinct answer. 9.28e+04. In the year 1995, what is the difference between the Number of refugees of Afghanistan and Number of refugees of Malawi?
Your answer should be compact. 1.86e+04. In the year 1996, what is the difference between the Number of refugees in East Asia (developing only) and Number of refugees in Latin America(all income levels)?
Offer a very short reply. 3.62e+05. In the year 1996, what is the difference between the Number of refugees in East Asia (developing only) and Number of refugees in Afghanistan?
Give a very brief answer. 4.32e+05. In the year 1996, what is the difference between the Number of refugees of East Asia (developing only) and Number of refugees of Malawi?
Offer a very short reply. 4.49e+05. In the year 1996, what is the difference between the Number of refugees in Latin America(all income levels) and Number of refugees in Afghanistan?
Provide a succinct answer. 6.96e+04. In the year 1996, what is the difference between the Number of refugees of Latin America(all income levels) and Number of refugees of Malawi?
Ensure brevity in your answer.  8.72e+04. In the year 1996, what is the difference between the Number of refugees in Afghanistan and Number of refugees in Malawi?
Keep it short and to the point. 1.75e+04. In the year 1997, what is the difference between the Number of refugees in East Asia (developing only) and Number of refugees in Latin America(all income levels)?
Ensure brevity in your answer.  4.07e+05. In the year 1997, what is the difference between the Number of refugees in East Asia (developing only) and Number of refugees in Afghanistan?
Offer a very short reply. 4.90e+05. In the year 1997, what is the difference between the Number of refugees of East Asia (developing only) and Number of refugees of Malawi?
Offer a terse response. 4.90e+05. In the year 1997, what is the difference between the Number of refugees in Latin America(all income levels) and Number of refugees in Afghanistan?
Your response must be concise. 8.32e+04. In the year 1997, what is the difference between the Number of refugees of Latin America(all income levels) and Number of refugees of Malawi?
Your answer should be very brief. 8.29e+04. In the year 1997, what is the difference between the Number of refugees in Afghanistan and Number of refugees in Malawi?
Your answer should be very brief. -275. In the year 2001, what is the difference between the Number of refugees of East Asia (developing only) and Number of refugees of Latin America(all income levels)?
Keep it short and to the point. 5.14e+05. In the year 2001, what is the difference between the Number of refugees in East Asia (developing only) and Number of refugees in Afghanistan?
Provide a succinct answer. 5.51e+05. In the year 2001, what is the difference between the Number of refugees in East Asia (developing only) and Number of refugees in Malawi?
Provide a succinct answer. 5.45e+05. In the year 2001, what is the difference between the Number of refugees in Latin America(all income levels) and Number of refugees in Afghanistan?
Offer a terse response. 3.71e+04. In the year 2001, what is the difference between the Number of refugees in Latin America(all income levels) and Number of refugees in Malawi?
Offer a very short reply. 3.09e+04. In the year 2001, what is the difference between the Number of refugees of Afghanistan and Number of refugees of Malawi?
Provide a short and direct response. -6194. In the year 2002, what is the difference between the Number of refugees of East Asia (developing only) and Number of refugees of Latin America(all income levels)?
Give a very brief answer. 4.69e+05. In the year 2002, what is the difference between the Number of refugees of East Asia (developing only) and Number of refugees of Afghanistan?
Give a very brief answer. 5.10e+05. In the year 2002, what is the difference between the Number of refugees in East Asia (developing only) and Number of refugees in Malawi?
Your answer should be compact. 5.08e+05. In the year 2002, what is the difference between the Number of refugees in Latin America(all income levels) and Number of refugees in Afghanistan?
Offer a terse response. 4.09e+04. In the year 2002, what is the difference between the Number of refugees in Latin America(all income levels) and Number of refugees in Malawi?
Keep it short and to the point. 3.87e+04. In the year 2002, what is the difference between the Number of refugees in Afghanistan and Number of refugees in Malawi?
Provide a short and direct response. -2163. In the year 2003, what is the difference between the Number of refugees of East Asia (developing only) and Number of refugees of Latin America(all income levels)?
Your answer should be compact. 4.11e+05. In the year 2003, what is the difference between the Number of refugees in East Asia (developing only) and Number of refugees in Afghanistan?
Give a very brief answer. 4.49e+05. In the year 2003, what is the difference between the Number of refugees in East Asia (developing only) and Number of refugees in Malawi?
Keep it short and to the point. 4.46e+05. In the year 2003, what is the difference between the Number of refugees of Latin America(all income levels) and Number of refugees of Afghanistan?
Provide a short and direct response. 3.83e+04. In the year 2003, what is the difference between the Number of refugees in Latin America(all income levels) and Number of refugees in Malawi?
Give a very brief answer. 3.51e+04. In the year 2003, what is the difference between the Number of refugees of Afghanistan and Number of refugees of Malawi?
Offer a very short reply. -3180. What is the ratio of the Number of refugees of East Asia (developing only) in 1993 to that in 1994?
Make the answer very short. 1.04. What is the ratio of the Number of refugees of Latin America(all income levels) in 1993 to that in 1994?
Give a very brief answer. 1.15. What is the ratio of the Number of refugees of Afghanistan in 1993 to that in 1994?
Ensure brevity in your answer.  1.68. What is the ratio of the Number of refugees in Malawi in 1993 to that in 1994?
Make the answer very short. 7.91. What is the ratio of the Number of refugees in East Asia (developing only) in 1993 to that in 1995?
Your answer should be compact. 0.95. What is the ratio of the Number of refugees in Latin America(all income levels) in 1993 to that in 1995?
Ensure brevity in your answer.  1.33. What is the ratio of the Number of refugees of Afghanistan in 1993 to that in 1995?
Offer a terse response. 1.64. What is the ratio of the Number of refugees in Malawi in 1993 to that in 1995?
Your answer should be compact. 700.99. What is the ratio of the Number of refugees in East Asia (developing only) in 1993 to that in 1996?
Your response must be concise. 0.94. What is the ratio of the Number of refugees of Latin America(all income levels) in 1993 to that in 1996?
Offer a very short reply. 1.42. What is the ratio of the Number of refugees in Afghanistan in 1993 to that in 1996?
Give a very brief answer. 1.71. What is the ratio of the Number of refugees of Malawi in 1993 to that in 1996?
Give a very brief answer. 562.78. What is the ratio of the Number of refugees in East Asia (developing only) in 1993 to that in 1997?
Offer a very short reply. 0.87. What is the ratio of the Number of refugees in Latin America(all income levels) in 1993 to that in 1997?
Give a very brief answer. 1.51. What is the ratio of the Number of refugees in Afghanistan in 1993 to that in 1997?
Offer a very short reply. 6426.4. What is the ratio of the Number of refugees of Malawi in 1993 to that in 1997?
Provide a succinct answer. 2548.6. What is the ratio of the Number of refugees in East Asia (developing only) in 1993 to that in 2001?
Ensure brevity in your answer.  0.77. What is the ratio of the Number of refugees of Latin America(all income levels) in 1993 to that in 2001?
Keep it short and to the point. 3.37. What is the ratio of the Number of refugees in Afghanistan in 1993 to that in 2001?
Offer a very short reply. 5355.33. What is the ratio of the Number of refugees of Malawi in 1993 to that in 2001?
Offer a terse response. 115.1. What is the ratio of the Number of refugees of East Asia (developing only) in 1993 to that in 2002?
Your answer should be compact. 0.83. What is the ratio of the Number of refugees in Latin America(all income levels) in 1993 to that in 2002?
Your response must be concise. 3.06. What is the ratio of the Number of refugees in Afghanistan in 1993 to that in 2002?
Offer a very short reply. 1.07e+04. What is the ratio of the Number of refugees in Malawi in 1993 to that in 2002?
Your response must be concise. 329.46. What is the ratio of the Number of refugees of East Asia (developing only) in 1993 to that in 2003?
Offer a terse response. 0.95. What is the ratio of the Number of refugees in Latin America(all income levels) in 1993 to that in 2003?
Your answer should be very brief. 3.27. What is the ratio of the Number of refugees of Afghanistan in 1993 to that in 2003?
Make the answer very short. 1460.55. What is the ratio of the Number of refugees in Malawi in 1993 to that in 2003?
Your answer should be very brief. 222.86. What is the ratio of the Number of refugees in East Asia (developing only) in 1994 to that in 1995?
Give a very brief answer. 0.91. What is the ratio of the Number of refugees in Latin America(all income levels) in 1994 to that in 1995?
Make the answer very short. 1.16. What is the ratio of the Number of refugees of Afghanistan in 1994 to that in 1995?
Provide a succinct answer. 0.98. What is the ratio of the Number of refugees in Malawi in 1994 to that in 1995?
Make the answer very short. 88.65. What is the ratio of the Number of refugees of East Asia (developing only) in 1994 to that in 1996?
Provide a short and direct response. 0.9. What is the ratio of the Number of refugees of Latin America(all income levels) in 1994 to that in 1996?
Ensure brevity in your answer.  1.23. What is the ratio of the Number of refugees of Afghanistan in 1994 to that in 1996?
Provide a short and direct response. 1.02. What is the ratio of the Number of refugees in Malawi in 1994 to that in 1996?
Your answer should be very brief. 71.17. What is the ratio of the Number of refugees in East Asia (developing only) in 1994 to that in 1997?
Offer a very short reply. 0.83. What is the ratio of the Number of refugees in Latin America(all income levels) in 1994 to that in 1997?
Give a very brief answer. 1.31. What is the ratio of the Number of refugees of Afghanistan in 1994 to that in 1997?
Your answer should be compact. 3826.2. What is the ratio of the Number of refugees of Malawi in 1994 to that in 1997?
Your response must be concise. 322.29. What is the ratio of the Number of refugees of East Asia (developing only) in 1994 to that in 2001?
Your answer should be compact. 0.74. What is the ratio of the Number of refugees in Latin America(all income levels) in 1994 to that in 2001?
Make the answer very short. 2.94. What is the ratio of the Number of refugees in Afghanistan in 1994 to that in 2001?
Provide a succinct answer. 3188.5. What is the ratio of the Number of refugees in Malawi in 1994 to that in 2001?
Offer a terse response. 14.56. What is the ratio of the Number of refugees in East Asia (developing only) in 1994 to that in 2002?
Give a very brief answer. 0.8. What is the ratio of the Number of refugees of Latin America(all income levels) in 1994 to that in 2002?
Offer a very short reply. 2.67. What is the ratio of the Number of refugees in Afghanistan in 1994 to that in 2002?
Provide a short and direct response. 6377. What is the ratio of the Number of refugees of Malawi in 1994 to that in 2002?
Give a very brief answer. 41.66. What is the ratio of the Number of refugees of East Asia (developing only) in 1994 to that in 2003?
Keep it short and to the point. 0.91. What is the ratio of the Number of refugees in Latin America(all income levels) in 1994 to that in 2003?
Provide a short and direct response. 2.85. What is the ratio of the Number of refugees of Afghanistan in 1994 to that in 2003?
Provide a succinct answer. 869.59. What is the ratio of the Number of refugees in Malawi in 1994 to that in 2003?
Provide a succinct answer. 28.18. What is the ratio of the Number of refugees of East Asia (developing only) in 1995 to that in 1996?
Keep it short and to the point. 0.99. What is the ratio of the Number of refugees in Latin America(all income levels) in 1995 to that in 1996?
Offer a terse response. 1.06. What is the ratio of the Number of refugees in Afghanistan in 1995 to that in 1996?
Your response must be concise. 1.04. What is the ratio of the Number of refugees of Malawi in 1995 to that in 1996?
Your answer should be compact. 0.8. What is the ratio of the Number of refugees in East Asia (developing only) in 1995 to that in 1997?
Offer a very short reply. 0.91. What is the ratio of the Number of refugees of Latin America(all income levels) in 1995 to that in 1997?
Your answer should be compact. 1.13. What is the ratio of the Number of refugees of Afghanistan in 1995 to that in 1997?
Keep it short and to the point. 3921. What is the ratio of the Number of refugees of Malawi in 1995 to that in 1997?
Provide a short and direct response. 3.64. What is the ratio of the Number of refugees of East Asia (developing only) in 1995 to that in 2001?
Your answer should be compact. 0.81. What is the ratio of the Number of refugees of Latin America(all income levels) in 1995 to that in 2001?
Make the answer very short. 2.53. What is the ratio of the Number of refugees of Afghanistan in 1995 to that in 2001?
Give a very brief answer. 3267.5. What is the ratio of the Number of refugees in Malawi in 1995 to that in 2001?
Make the answer very short. 0.16. What is the ratio of the Number of refugees in East Asia (developing only) in 1995 to that in 2002?
Your answer should be compact. 0.88. What is the ratio of the Number of refugees in Latin America(all income levels) in 1995 to that in 2002?
Ensure brevity in your answer.  2.3. What is the ratio of the Number of refugees of Afghanistan in 1995 to that in 2002?
Offer a terse response. 6535. What is the ratio of the Number of refugees in Malawi in 1995 to that in 2002?
Offer a terse response. 0.47. What is the ratio of the Number of refugees in Latin America(all income levels) in 1995 to that in 2003?
Offer a terse response. 2.45. What is the ratio of the Number of refugees of Afghanistan in 1995 to that in 2003?
Your answer should be very brief. 891.14. What is the ratio of the Number of refugees in Malawi in 1995 to that in 2003?
Keep it short and to the point. 0.32. What is the ratio of the Number of refugees in East Asia (developing only) in 1996 to that in 1997?
Provide a succinct answer. 0.92. What is the ratio of the Number of refugees of Afghanistan in 1996 to that in 1997?
Give a very brief answer. 3755. What is the ratio of the Number of refugees of Malawi in 1996 to that in 1997?
Offer a very short reply. 4.53. What is the ratio of the Number of refugees of East Asia (developing only) in 1996 to that in 2001?
Offer a very short reply. 0.82. What is the ratio of the Number of refugees in Latin America(all income levels) in 1996 to that in 2001?
Give a very brief answer. 2.38. What is the ratio of the Number of refugees of Afghanistan in 1996 to that in 2001?
Your answer should be very brief. 3129.17. What is the ratio of the Number of refugees in Malawi in 1996 to that in 2001?
Your answer should be compact. 0.2. What is the ratio of the Number of refugees of East Asia (developing only) in 1996 to that in 2002?
Offer a very short reply. 0.88. What is the ratio of the Number of refugees in Latin America(all income levels) in 1996 to that in 2002?
Offer a very short reply. 2.16. What is the ratio of the Number of refugees of Afghanistan in 1996 to that in 2002?
Provide a short and direct response. 6258.33. What is the ratio of the Number of refugees of Malawi in 1996 to that in 2002?
Your answer should be very brief. 0.59. What is the ratio of the Number of refugees of East Asia (developing only) in 1996 to that in 2003?
Provide a succinct answer. 1. What is the ratio of the Number of refugees of Latin America(all income levels) in 1996 to that in 2003?
Offer a very short reply. 2.31. What is the ratio of the Number of refugees in Afghanistan in 1996 to that in 2003?
Keep it short and to the point. 853.41. What is the ratio of the Number of refugees in Malawi in 1996 to that in 2003?
Make the answer very short. 0.4. What is the ratio of the Number of refugees in East Asia (developing only) in 1997 to that in 2001?
Provide a short and direct response. 0.89. What is the ratio of the Number of refugees of Latin America(all income levels) in 1997 to that in 2001?
Your response must be concise. 2.24. What is the ratio of the Number of refugees of Malawi in 1997 to that in 2001?
Your response must be concise. 0.05. What is the ratio of the Number of refugees of East Asia (developing only) in 1997 to that in 2002?
Your answer should be very brief. 0.96. What is the ratio of the Number of refugees of Latin America(all income levels) in 1997 to that in 2002?
Your response must be concise. 2.04. What is the ratio of the Number of refugees in Afghanistan in 1997 to that in 2002?
Ensure brevity in your answer.  1.67. What is the ratio of the Number of refugees in Malawi in 1997 to that in 2002?
Give a very brief answer. 0.13. What is the ratio of the Number of refugees of East Asia (developing only) in 1997 to that in 2003?
Ensure brevity in your answer.  1.09. What is the ratio of the Number of refugees in Latin America(all income levels) in 1997 to that in 2003?
Your answer should be compact. 2.17. What is the ratio of the Number of refugees in Afghanistan in 1997 to that in 2003?
Offer a terse response. 0.23. What is the ratio of the Number of refugees of Malawi in 1997 to that in 2003?
Make the answer very short. 0.09. What is the ratio of the Number of refugees of East Asia (developing only) in 2001 to that in 2002?
Give a very brief answer. 1.08. What is the ratio of the Number of refugees of Latin America(all income levels) in 2001 to that in 2002?
Keep it short and to the point. 0.91. What is the ratio of the Number of refugees in Malawi in 2001 to that in 2002?
Ensure brevity in your answer.  2.86. What is the ratio of the Number of refugees in East Asia (developing only) in 2001 to that in 2003?
Your response must be concise. 1.23. What is the ratio of the Number of refugees of Latin America(all income levels) in 2001 to that in 2003?
Your answer should be very brief. 0.97. What is the ratio of the Number of refugees in Afghanistan in 2001 to that in 2003?
Your answer should be compact. 0.27. What is the ratio of the Number of refugees in Malawi in 2001 to that in 2003?
Your answer should be compact. 1.94. What is the ratio of the Number of refugees of East Asia (developing only) in 2002 to that in 2003?
Ensure brevity in your answer.  1.14. What is the ratio of the Number of refugees of Latin America(all income levels) in 2002 to that in 2003?
Provide a short and direct response. 1.07. What is the ratio of the Number of refugees in Afghanistan in 2002 to that in 2003?
Provide a succinct answer. 0.14. What is the ratio of the Number of refugees in Malawi in 2002 to that in 2003?
Make the answer very short. 0.68. What is the difference between the highest and the second highest Number of refugees in East Asia (developing only)?
Your answer should be very brief. 4.08e+04. What is the difference between the highest and the second highest Number of refugees of Latin America(all income levels)?
Offer a very short reply. 1.62e+04. What is the difference between the highest and the second highest Number of refugees of Afghanistan?
Offer a very short reply. 1.25e+04. What is the difference between the highest and the second highest Number of refugees in Malawi?
Your answer should be very brief. 6.23e+05. What is the difference between the highest and the lowest Number of refugees of East Asia (developing only)?
Keep it short and to the point. 1.44e+05. What is the difference between the highest and the lowest Number of refugees in Latin America(all income levels)?
Offer a terse response. 8.82e+04. What is the difference between the highest and the lowest Number of refugees in Afghanistan?
Your response must be concise. 3.21e+04. What is the difference between the highest and the lowest Number of refugees of Malawi?
Your response must be concise. 7.13e+05. 